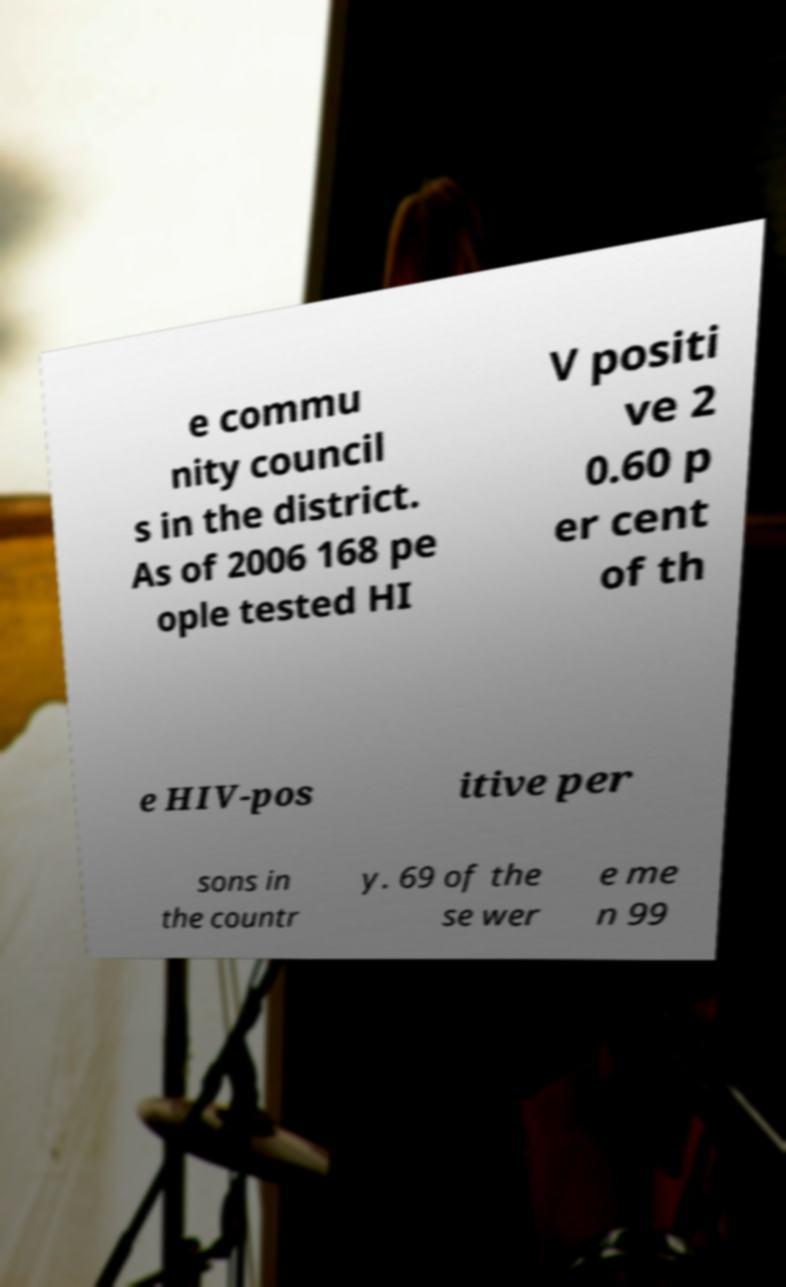Can you read and provide the text displayed in the image?This photo seems to have some interesting text. Can you extract and type it out for me? e commu nity council s in the district. As of 2006 168 pe ople tested HI V positi ve 2 0.60 p er cent of th e HIV-pos itive per sons in the countr y. 69 of the se wer e me n 99 